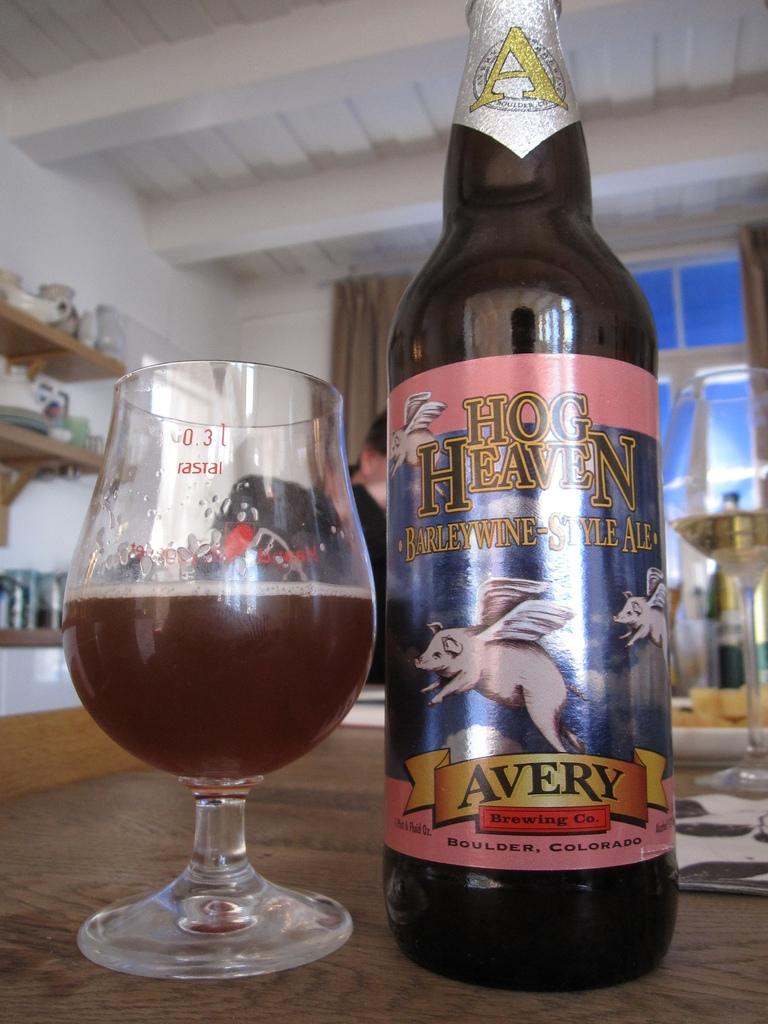<image>
Render a clear and concise summary of the photo. A glass next to a Hog heaven Barley Wine-Style Ale. 